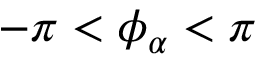<formula> <loc_0><loc_0><loc_500><loc_500>- \pi < \phi _ { \alpha } < \pi</formula> 